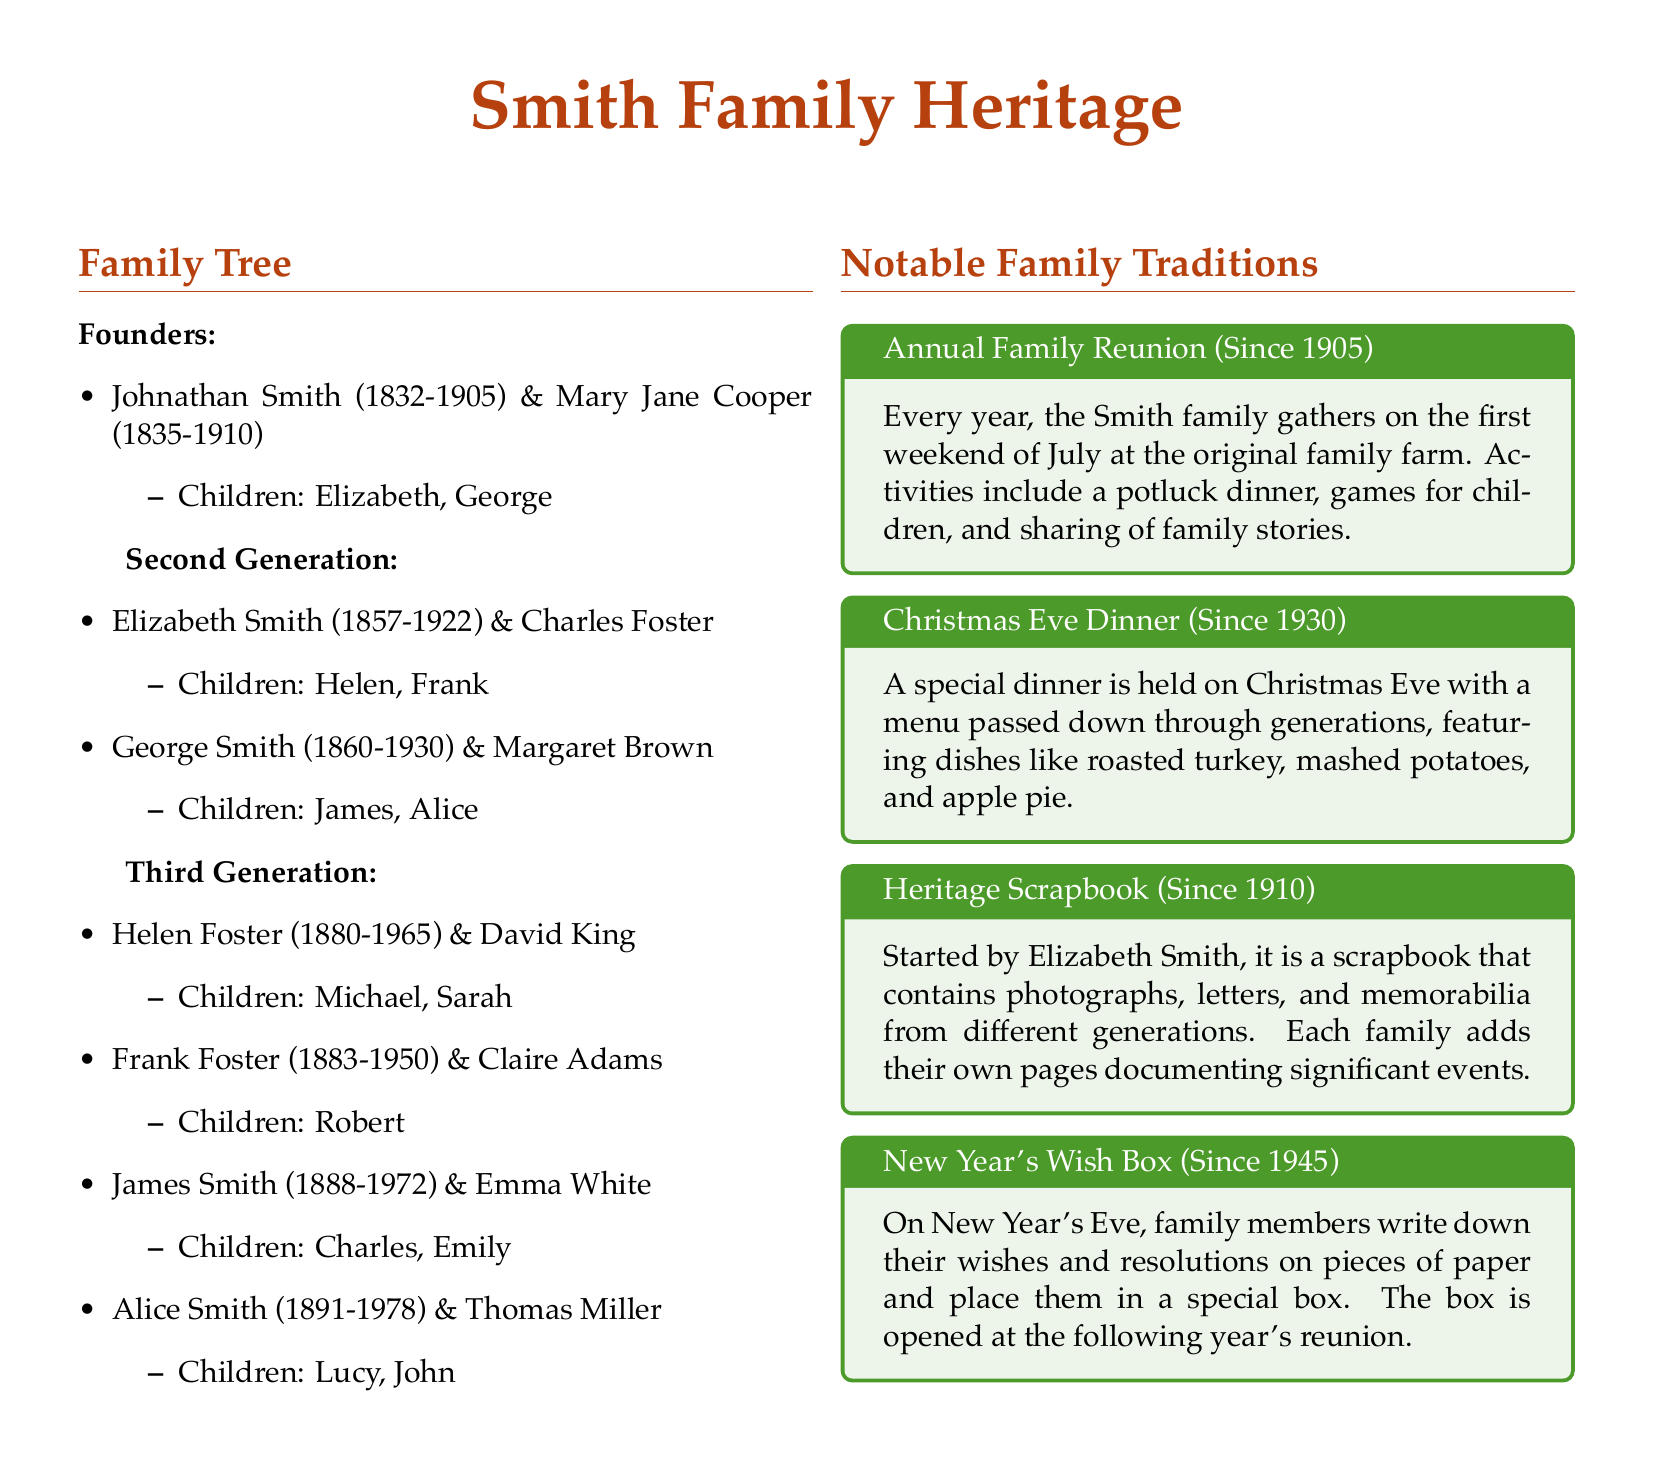what are the names of the founders? The founders of the family are listed as Johnathan Smith and Mary Jane Cooper in the document.
Answer: Johnathan Smith and Mary Jane Cooper what year did the first family reunion take place? The first family reunion is noted to have occurred in the year 1905.
Answer: 1905 who are the children of Elizabeth Smith? The children of Elizabeth Smith, as stated in the document, are Helen and Frank.
Answer: Helen, Frank what is the notable dinner tradition held on Christmas Eve? The document specifies that the Christmas Eve dinner features a menu passed down through generations.
Answer: Christmas Eve Dinner when did the Heritage Scrapbook tradition begin? The document states that the Heritage Scrapbook was started in the year 1910.
Answer: 1910 which generation does Robert belong to? Robert is a child of Frank Foster, placing him in the third generation of the family tree.
Answer: Third Generation what event is celebrated on New Year's Eve according to the document? The document describes a tradition where family members write wishes and resolutions for a special box.
Answer: New Year's Wish Box how many children did George Smith have? In the document, it is detailed that George Smith had two children: James and Alice.
Answer: Two children 